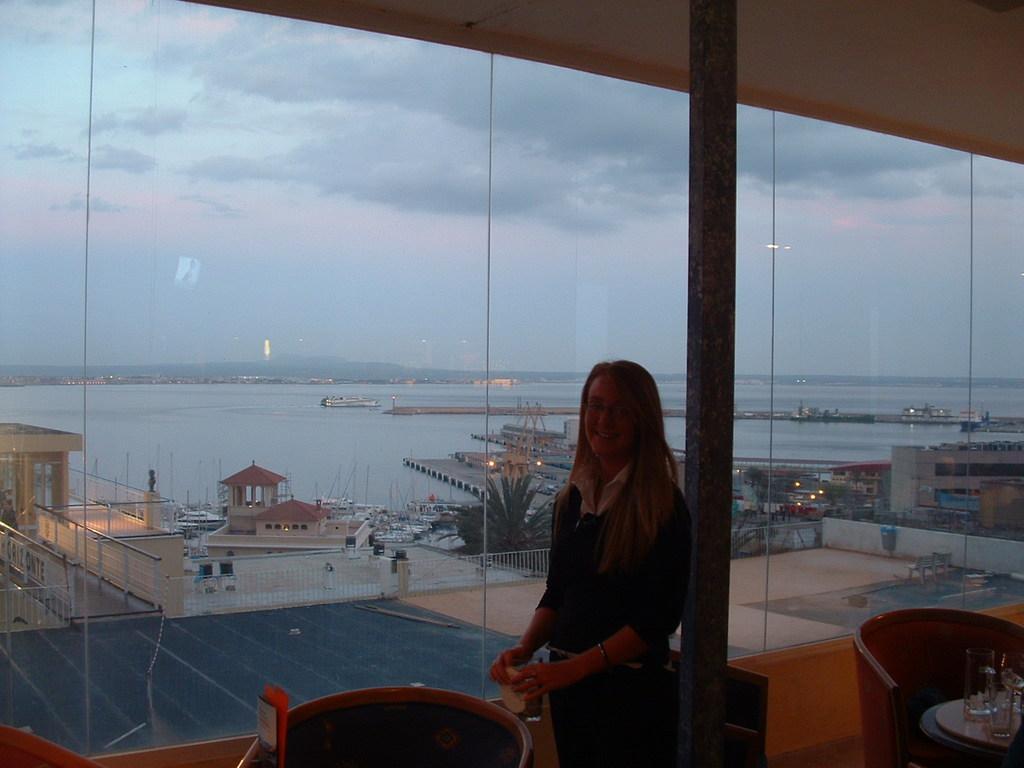Please provide a concise description of this image. The women is wearing black dress is standing and there are buildings,a port and river in the background. 